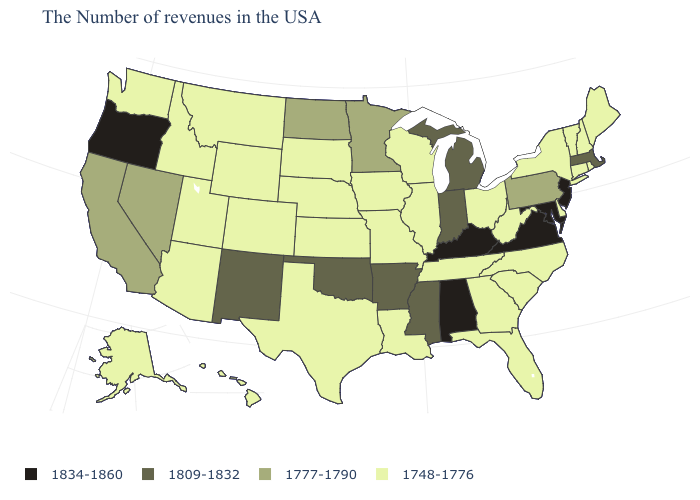Name the states that have a value in the range 1777-1790?
Be succinct. Pennsylvania, Minnesota, North Dakota, Nevada, California. Is the legend a continuous bar?
Short answer required. No. Name the states that have a value in the range 1809-1832?
Answer briefly. Massachusetts, Michigan, Indiana, Mississippi, Arkansas, Oklahoma, New Mexico. How many symbols are there in the legend?
Keep it brief. 4. How many symbols are there in the legend?
Concise answer only. 4. Does New York have the same value as Nevada?
Answer briefly. No. What is the highest value in the West ?
Be succinct. 1834-1860. Which states have the lowest value in the West?
Give a very brief answer. Wyoming, Colorado, Utah, Montana, Arizona, Idaho, Washington, Alaska, Hawaii. Does the first symbol in the legend represent the smallest category?
Concise answer only. No. Does New York have the same value as Florida?
Keep it brief. Yes. Which states have the highest value in the USA?
Concise answer only. New Jersey, Maryland, Virginia, Kentucky, Alabama, Oregon. What is the value of Connecticut?
Be succinct. 1748-1776. Name the states that have a value in the range 1834-1860?
Write a very short answer. New Jersey, Maryland, Virginia, Kentucky, Alabama, Oregon. How many symbols are there in the legend?
Short answer required. 4. What is the value of Ohio?
Write a very short answer. 1748-1776. 